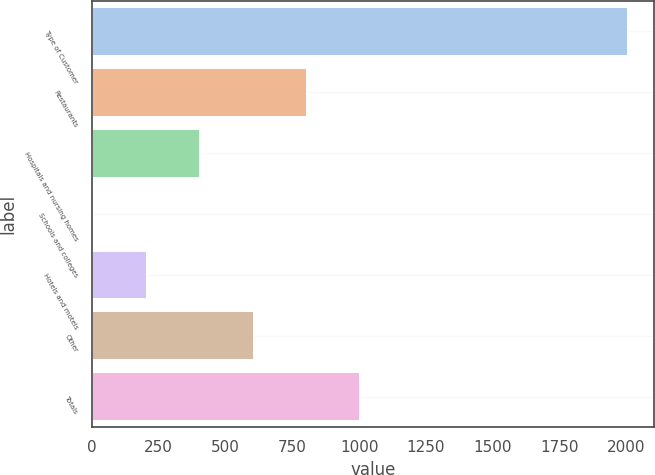Convert chart to OTSL. <chart><loc_0><loc_0><loc_500><loc_500><bar_chart><fcel>Type of Customer<fcel>Restaurants<fcel>Hospitals and nursing homes<fcel>Schools and colleges<fcel>Hotels and motels<fcel>Other<fcel>Totals<nl><fcel>2005<fcel>805<fcel>405<fcel>5<fcel>205<fcel>605<fcel>1005<nl></chart> 